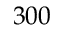<formula> <loc_0><loc_0><loc_500><loc_500>3 0 0</formula> 